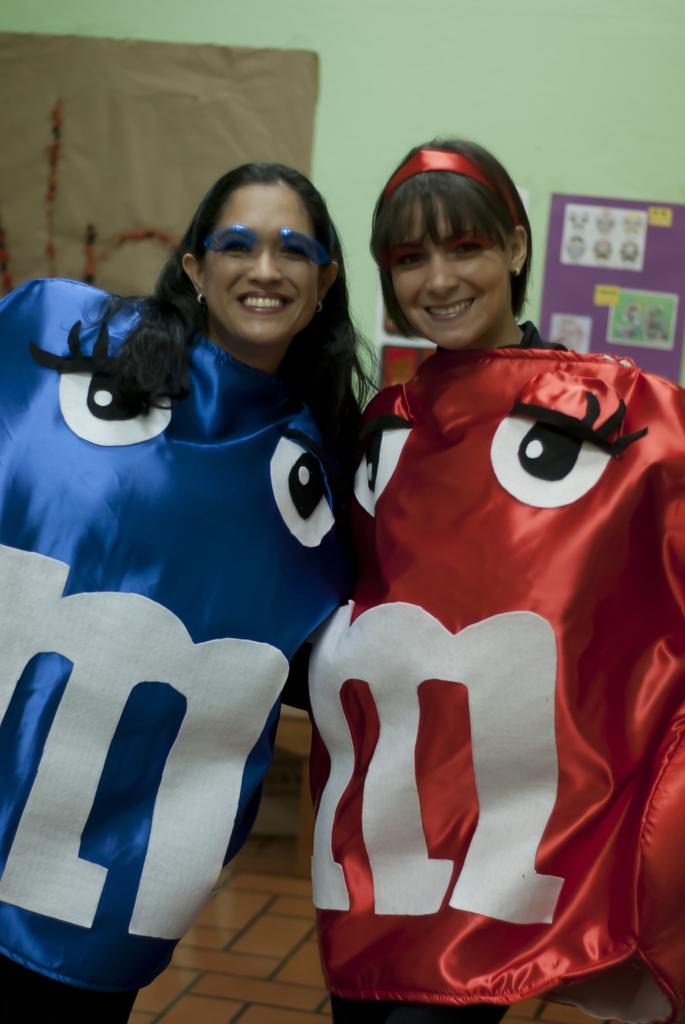What is the appearance of the woman on the right side of the image? The woman on the right side is wearing a red dress and smiling. How many women are present in the image? There are two women in the image. What is the appearance of the woman on the left side of the image? The woman on the left side is wearing a black dress. What can be seen in the background of the image? There is a wall in the background of the image. What type of houses can be seen in the background of the image? There are no houses visible in the background of the image; only a wall is present. Is there a shop or store visible in the image? There is no shop or store visible in the image. 